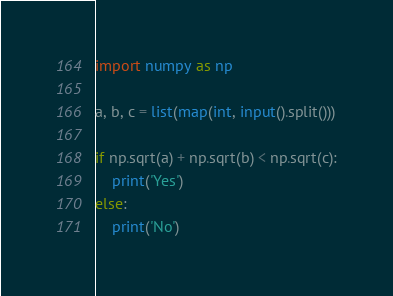<code> <loc_0><loc_0><loc_500><loc_500><_Python_>import numpy as np

a, b, c = list(map(int, input().split()))

if np.sqrt(a) + np.sqrt(b) < np.sqrt(c):
    print('Yes')
else:
    print('No')</code> 